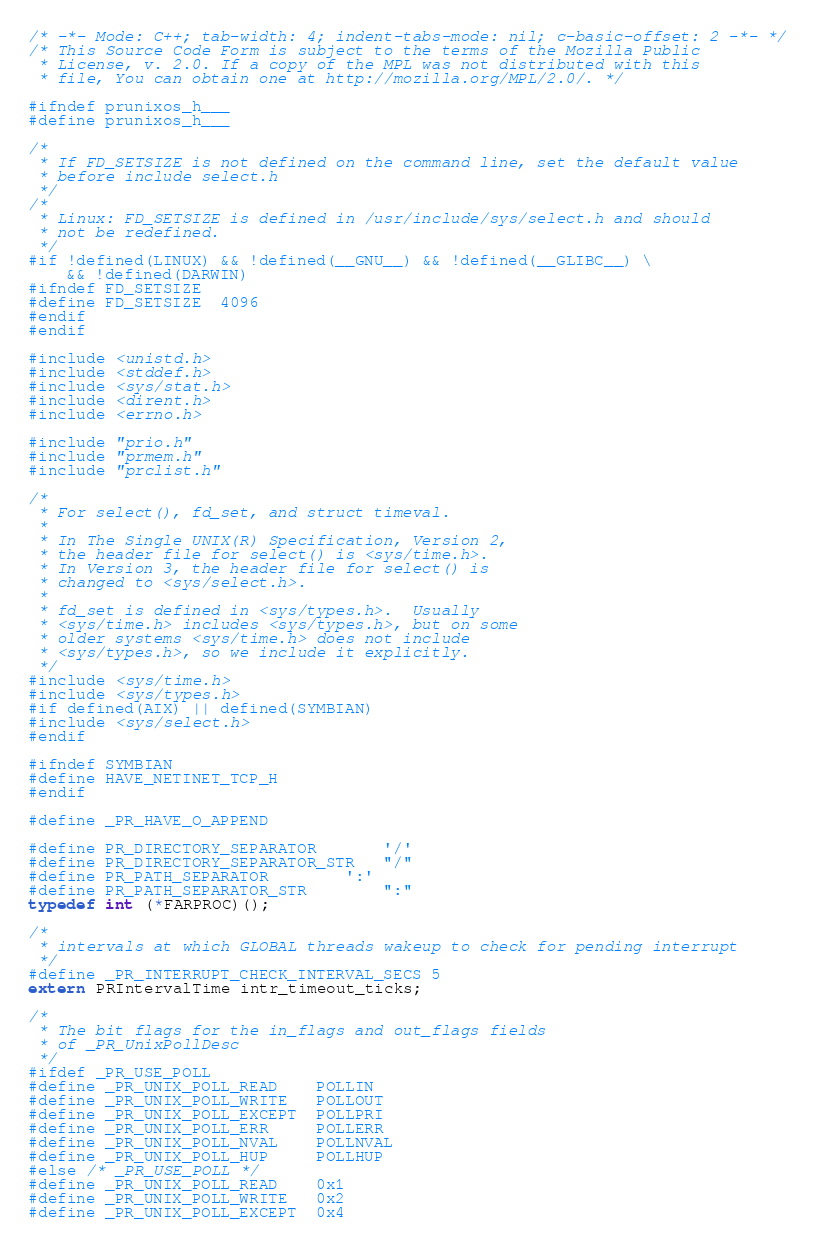<code> <loc_0><loc_0><loc_500><loc_500><_C_>/* -*- Mode: C++; tab-width: 4; indent-tabs-mode: nil; c-basic-offset: 2 -*- */
/* This Source Code Form is subject to the terms of the Mozilla Public
 * License, v. 2.0. If a copy of the MPL was not distributed with this
 * file, You can obtain one at http://mozilla.org/MPL/2.0/. */

#ifndef prunixos_h___
#define prunixos_h___

/*
 * If FD_SETSIZE is not defined on the command line, set the default value
 * before include select.h
 */
/*
 * Linux: FD_SETSIZE is defined in /usr/include/sys/select.h and should
 * not be redefined.
 */
#if !defined(LINUX) && !defined(__GNU__) && !defined(__GLIBC__) \
    && !defined(DARWIN)
#ifndef FD_SETSIZE
#define FD_SETSIZE  4096
#endif
#endif

#include <unistd.h>
#include <stddef.h>
#include <sys/stat.h>
#include <dirent.h>
#include <errno.h>

#include "prio.h"
#include "prmem.h"
#include "prclist.h"

/*
 * For select(), fd_set, and struct timeval.
 *
 * In The Single UNIX(R) Specification, Version 2,
 * the header file for select() is <sys/time.h>.
 * In Version 3, the header file for select() is
 * changed to <sys/select.h>.
 *
 * fd_set is defined in <sys/types.h>.  Usually
 * <sys/time.h> includes <sys/types.h>, but on some
 * older systems <sys/time.h> does not include
 * <sys/types.h>, so we include it explicitly.
 */
#include <sys/time.h>
#include <sys/types.h>
#if defined(AIX) || defined(SYMBIAN)
#include <sys/select.h>
#endif

#ifndef SYMBIAN
#define HAVE_NETINET_TCP_H
#endif

#define _PR_HAVE_O_APPEND

#define PR_DIRECTORY_SEPARATOR		'/'
#define PR_DIRECTORY_SEPARATOR_STR	"/"
#define PR_PATH_SEPARATOR		':'
#define PR_PATH_SEPARATOR_STR		":"
typedef int (*FARPROC)();

/*
 * intervals at which GLOBAL threads wakeup to check for pending interrupt
 */
#define _PR_INTERRUPT_CHECK_INTERVAL_SECS 5
extern PRIntervalTime intr_timeout_ticks;

/*
 * The bit flags for the in_flags and out_flags fields
 * of _PR_UnixPollDesc
 */
#ifdef _PR_USE_POLL
#define _PR_UNIX_POLL_READ    POLLIN
#define _PR_UNIX_POLL_WRITE   POLLOUT
#define _PR_UNIX_POLL_EXCEPT  POLLPRI
#define _PR_UNIX_POLL_ERR     POLLERR
#define _PR_UNIX_POLL_NVAL    POLLNVAL
#define _PR_UNIX_POLL_HUP     POLLHUP
#else /* _PR_USE_POLL */
#define _PR_UNIX_POLL_READ    0x1
#define _PR_UNIX_POLL_WRITE   0x2
#define _PR_UNIX_POLL_EXCEPT  0x4</code> 